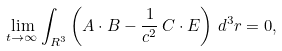<formula> <loc_0><loc_0><loc_500><loc_500>\lim _ { t \rightarrow \infty } \int _ { R ^ { 3 } } \left ( { A } \cdot { B } - \frac { 1 } { c ^ { 2 } } \, { C } \cdot { E } \right ) \, d ^ { 3 } r = 0 ,</formula> 